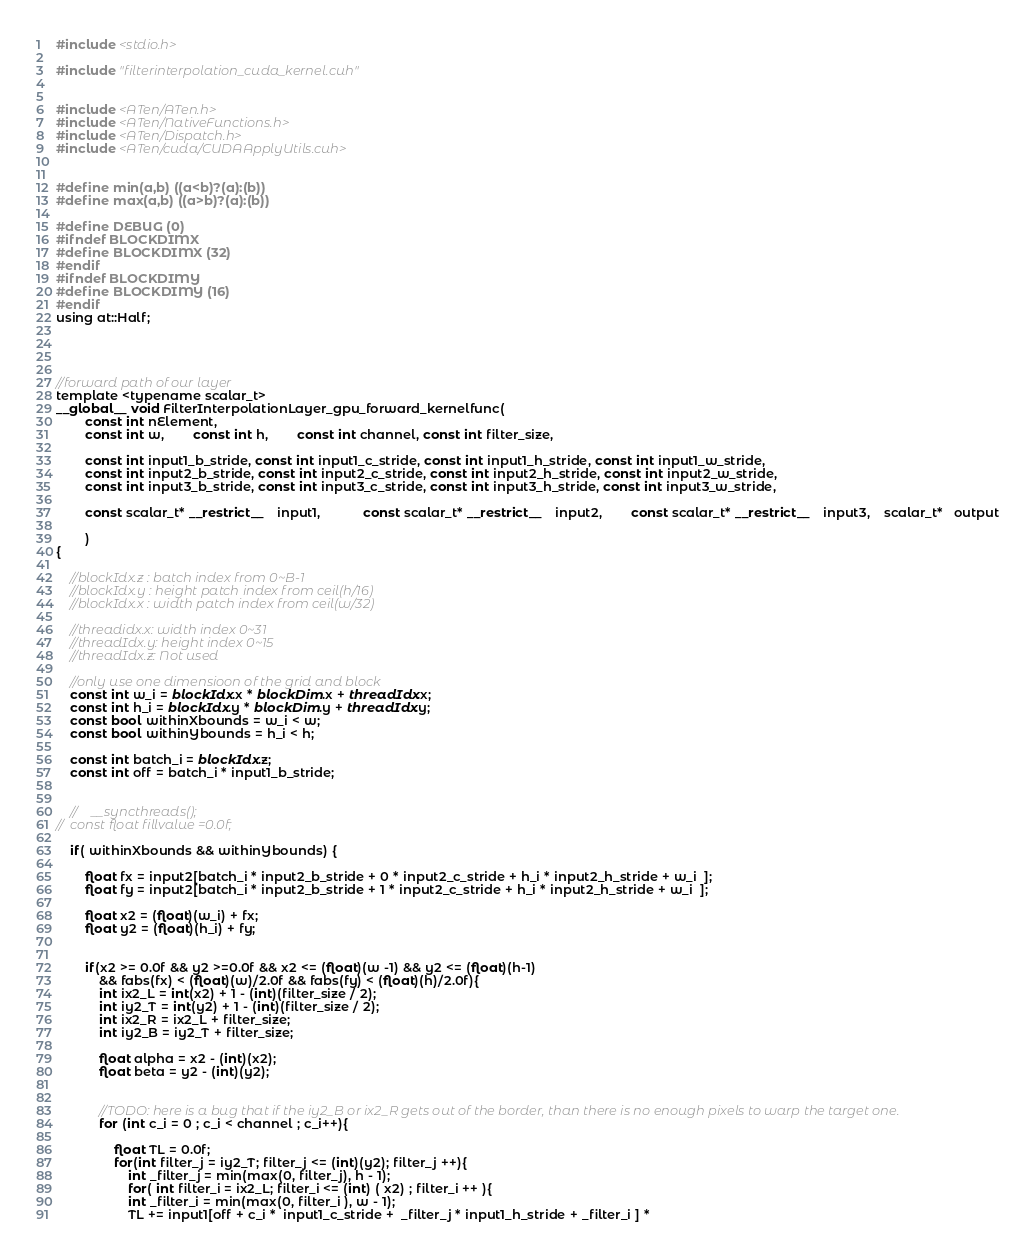Convert code to text. <code><loc_0><loc_0><loc_500><loc_500><_Cuda_>#include <stdio.h>

#include "filterinterpolation_cuda_kernel.cuh"


#include <ATen/ATen.h>
#include <ATen/NativeFunctions.h>
#include <ATen/Dispatch.h>
#include <ATen/cuda/CUDAApplyUtils.cuh>


#define min(a,b) ((a<b)?(a):(b))
#define max(a,b) ((a>b)?(a):(b))

#define DEBUG (0)
#ifndef BLOCKDIMX
#define BLOCKDIMX (32)
#endif
#ifndef BLOCKDIMY
#define BLOCKDIMY (16)
#endif
using at::Half;




//forward path of our layer
template <typename scalar_t>
__global__ void FilterInterpolationLayer_gpu_forward_kernelfunc(
		const int nElement,
		const int w, 		const int h, 		const int channel, const int filter_size,

		const int input1_b_stride, const int input1_c_stride, const int input1_h_stride, const int input1_w_stride,
		const int input2_b_stride, const int input2_c_stride, const int input2_h_stride, const int input2_w_stride,
		const int input3_b_stride, const int input3_c_stride, const int input3_h_stride, const int input3_w_stride,

		const scalar_t* __restrict__    input1,    		const scalar_t* __restrict__    input2,    	const scalar_t* __restrict__    input3, 	scalar_t*   output

		)
{

	//blockIdx.z : batch index from 0~B-1
	//blockIdx.y : height patch index from ceil(h/16)
	//blockIdx.x : width patch index from ceil(w/32)

	//threadidx.x: width index 0~31
	//threadIdx.y: height index 0~15
	//threadIdx.z: Not used

	//only use one dimensioon of the grid and block
	const int w_i = blockIdx.x * blockDim.x + threadIdx.x;
	const int h_i = blockIdx.y * blockDim.y + threadIdx.y;
	const bool withinXbounds = w_i < w;
	const bool withinYbounds = h_i < h;

	const int batch_i = blockIdx.z;
	const int off = batch_i * input1_b_stride;


	//    __syncthreads();
//	const float fillvalue =0.0f;

	if( withinXbounds && withinYbounds) {

		float fx = input2[batch_i * input2_b_stride + 0 * input2_c_stride + h_i * input2_h_stride + w_i  ];
		float fy = input2[batch_i * input2_b_stride + 1 * input2_c_stride + h_i * input2_h_stride + w_i  ];

		float x2 = (float)(w_i) + fx;
		float y2 = (float)(h_i) + fy;


		if(x2 >= 0.0f && y2 >=0.0f && x2 <= (float)(w -1) && y2 <= (float)(h-1)
            && fabs(fx) < (float)(w)/2.0f && fabs(fy) < (float)(h)/2.0f){
			int ix2_L = int(x2) + 1 - (int)(filter_size / 2);
			int iy2_T = int(y2) + 1 - (int)(filter_size / 2);
			int ix2_R = ix2_L + filter_size;
			int iy2_B = iy2_T + filter_size;

            float alpha = x2 - (int)(x2);
            float beta = y2 - (int)(y2);


			//TODO: here is a bug that if the iy2_B or ix2_R gets out of the border, than there is no enough pixels to warp the target one.
			for (int c_i = 0 ; c_i < channel ; c_i++){

                float TL = 0.0f;
                for(int filter_j = iy2_T; filter_j <= (int)(y2); filter_j ++){
                    int _filter_j = min(max(0, filter_j), h - 1);
                    for( int filter_i = ix2_L; filter_i <= (int) ( x2) ; filter_i ++ ){
                    int _filter_i = min(max(0, filter_i ), w - 1);
                    TL += input1[off + c_i *  input1_c_stride +  _filter_j * input1_h_stride + _filter_i ] *</code> 